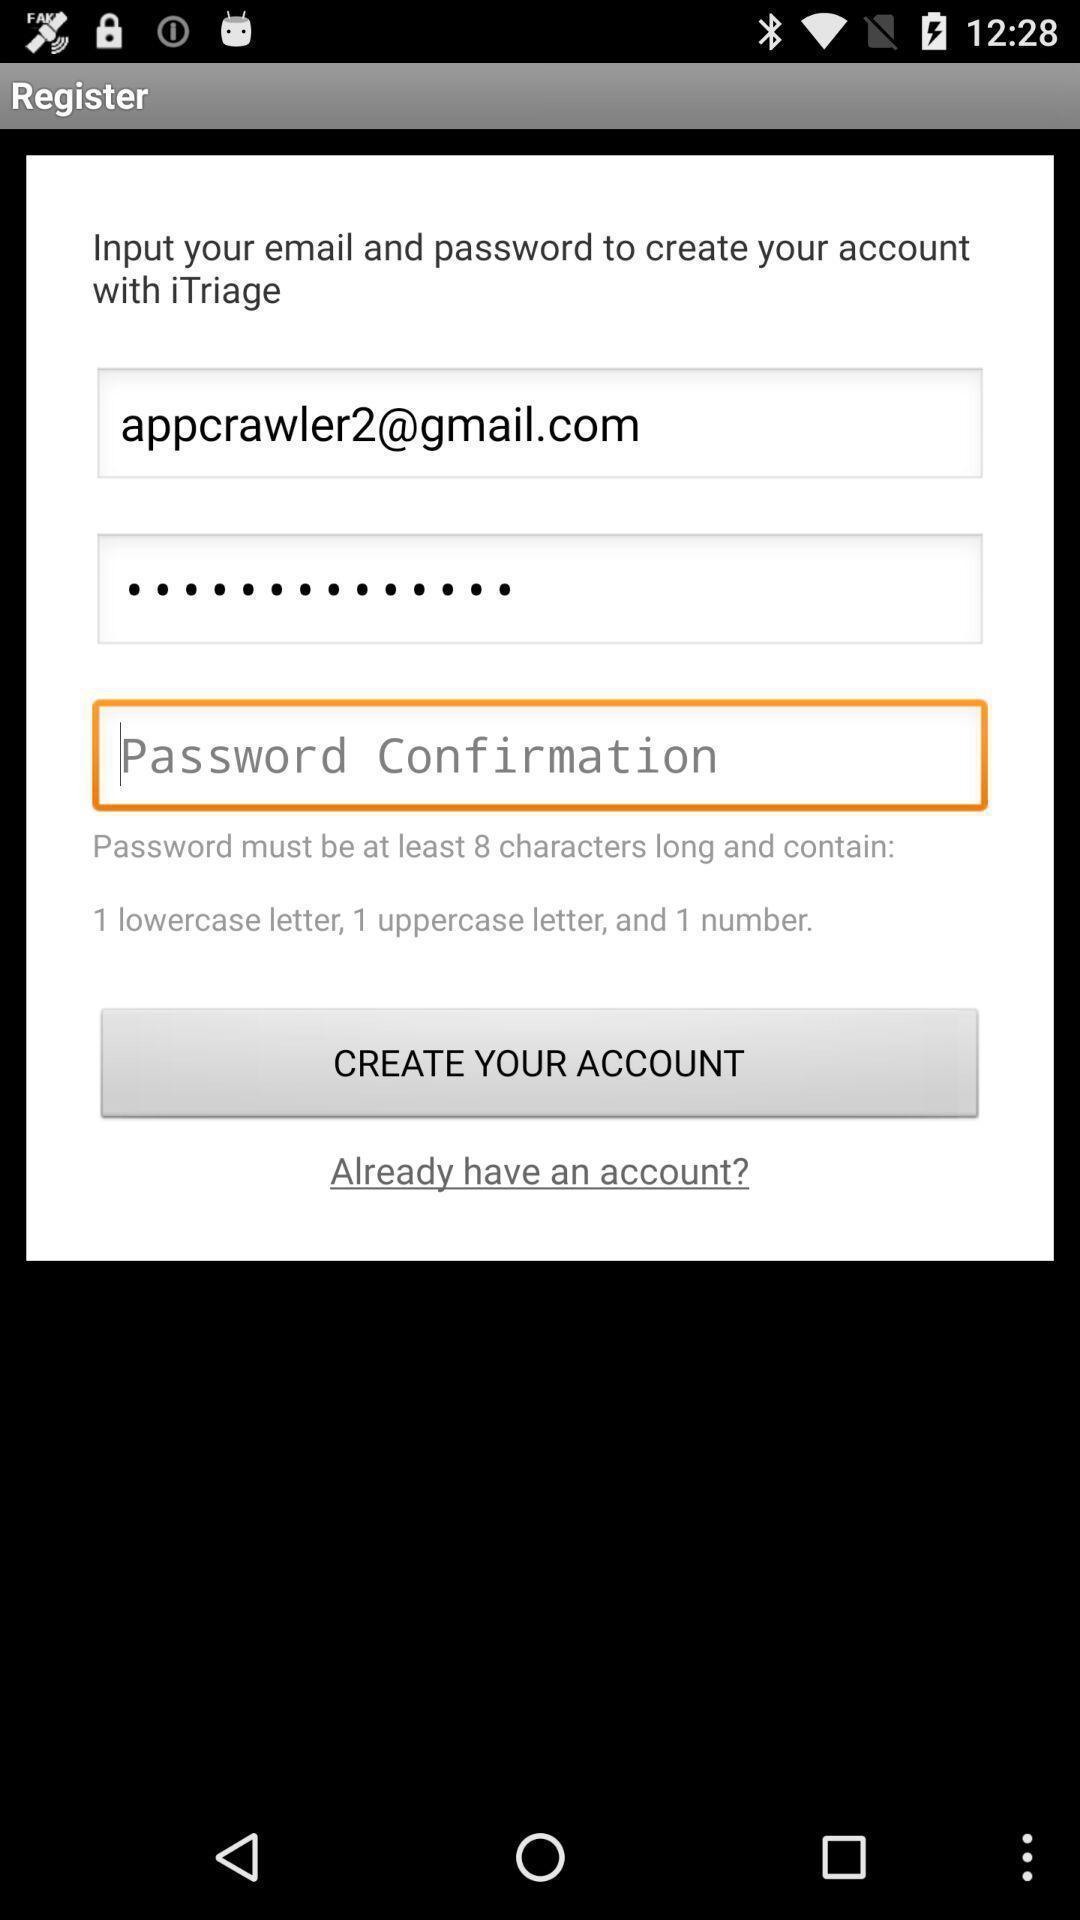What details can you identify in this image? Pop up displaying to confirm password. 